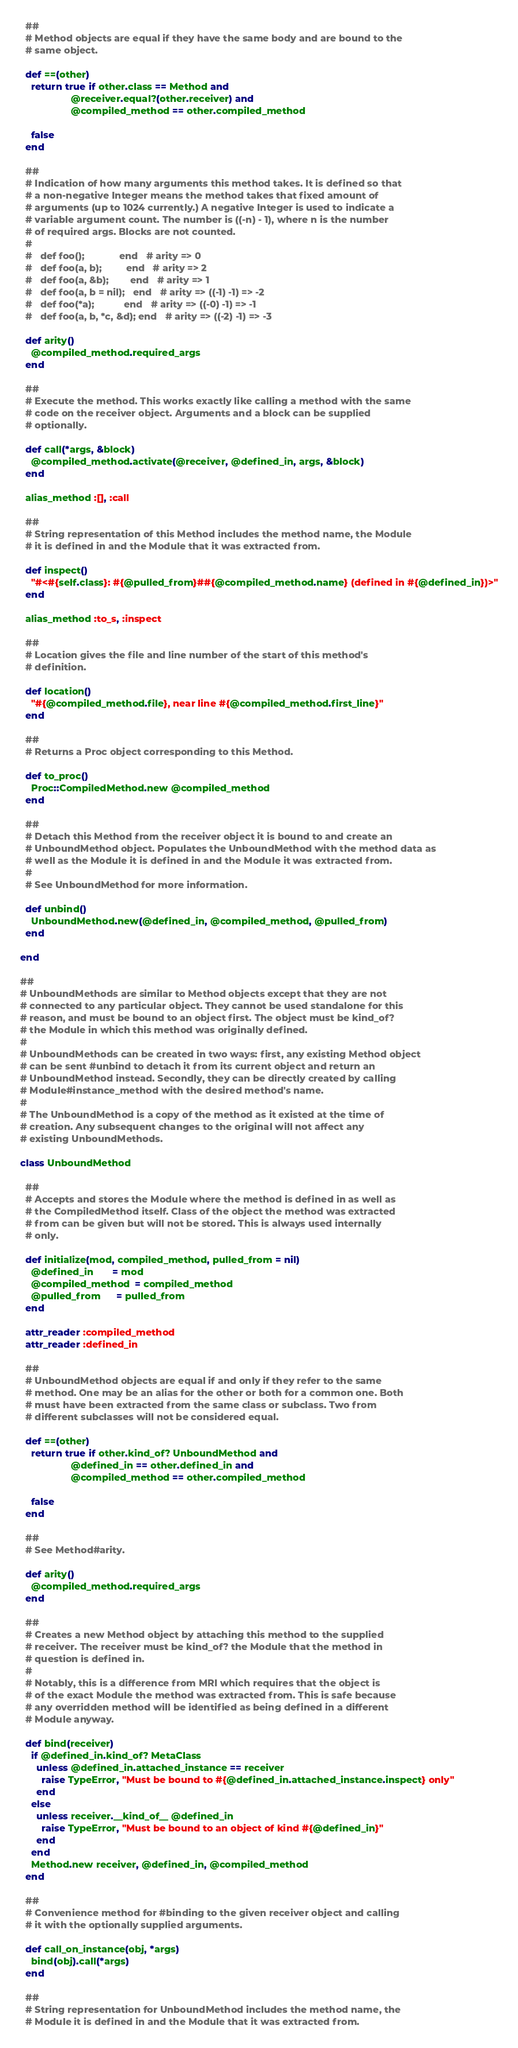Convert code to text. <code><loc_0><loc_0><loc_500><loc_500><_Ruby_>  ##
  # Method objects are equal if they have the same body and are bound to the
  # same object.

  def ==(other)
    return true if other.class == Method and
                   @receiver.equal?(other.receiver) and
                   @compiled_method == other.compiled_method

    false
  end

  ##
  # Indication of how many arguments this method takes. It is defined so that
  # a non-negative Integer means the method takes that fixed amount of
  # arguments (up to 1024 currently.) A negative Integer is used to indicate a
  # variable argument count. The number is ((-n) - 1), where n is the number
  # of required args. Blocks are not counted.
  #
  #   def foo();             end   # arity => 0
  #   def foo(a, b);         end   # arity => 2
  #   def foo(a, &b);        end   # arity => 1
  #   def foo(a, b = nil);   end   # arity => ((-1) -1) => -2
  #   def foo(*a);           end   # arity => ((-0) -1) => -1
  #   def foo(a, b, *c, &d); end   # arity => ((-2) -1) => -3

  def arity()
    @compiled_method.required_args
  end

  ##
  # Execute the method. This works exactly like calling a method with the same
  # code on the receiver object. Arguments and a block can be supplied
  # optionally.

  def call(*args, &block)
    @compiled_method.activate(@receiver, @defined_in, args, &block)
  end

  alias_method :[], :call

  ##
  # String representation of this Method includes the method name, the Module
  # it is defined in and the Module that it was extracted from.

  def inspect()
    "#<#{self.class}: #{@pulled_from}##{@compiled_method.name} (defined in #{@defined_in})>"
  end

  alias_method :to_s, :inspect

  ##
  # Location gives the file and line number of the start of this method's
  # definition.

  def location()
    "#{@compiled_method.file}, near line #{@compiled_method.first_line}"
  end

  ##
  # Returns a Proc object corresponding to this Method.

  def to_proc()
    Proc::CompiledMethod.new @compiled_method
  end

  ##
  # Detach this Method from the receiver object it is bound to and create an
  # UnboundMethod object. Populates the UnboundMethod with the method data as
  # well as the Module it is defined in and the Module it was extracted from.
  #
  # See UnboundMethod for more information.

  def unbind()
    UnboundMethod.new(@defined_in, @compiled_method, @pulled_from)
  end

end

##
# UnboundMethods are similar to Method objects except that they are not
# connected to any particular object. They cannot be used standalone for this
# reason, and must be bound to an object first. The object must be kind_of?
# the Module in which this method was originally defined.
#
# UnboundMethods can be created in two ways: first, any existing Method object
# can be sent #unbind to detach it from its current object and return an
# UnboundMethod instead. Secondly, they can be directly created by calling
# Module#instance_method with the desired method's name.
#
# The UnboundMethod is a copy of the method as it existed at the time of
# creation. Any subsequent changes to the original will not affect any
# existing UnboundMethods.

class UnboundMethod

  ##
  # Accepts and stores the Module where the method is defined in as well as
  # the CompiledMethod itself. Class of the object the method was extracted
  # from can be given but will not be stored. This is always used internally
  # only.

  def initialize(mod, compiled_method, pulled_from = nil)
    @defined_in       = mod
    @compiled_method  = compiled_method
    @pulled_from      = pulled_from
  end

  attr_reader :compiled_method
  attr_reader :defined_in

  ##
  # UnboundMethod objects are equal if and only if they refer to the same
  # method. One may be an alias for the other or both for a common one. Both
  # must have been extracted from the same class or subclass. Two from
  # different subclasses will not be considered equal.

  def ==(other)
    return true if other.kind_of? UnboundMethod and
                   @defined_in == other.defined_in and
                   @compiled_method == other.compiled_method

    false
  end

  ##
  # See Method#arity.

  def arity()
    @compiled_method.required_args
  end

  ##
  # Creates a new Method object by attaching this method to the supplied
  # receiver. The receiver must be kind_of? the Module that the method in
  # question is defined in.
  #
  # Notably, this is a difference from MRI which requires that the object is
  # of the exact Module the method was extracted from. This is safe because
  # any overridden method will be identified as being defined in a different
  # Module anyway.

  def bind(receiver)
    if @defined_in.kind_of? MetaClass
      unless @defined_in.attached_instance == receiver
        raise TypeError, "Must be bound to #{@defined_in.attached_instance.inspect} only"
      end
    else
      unless receiver.__kind_of__ @defined_in
        raise TypeError, "Must be bound to an object of kind #{@defined_in}"
      end
    end
    Method.new receiver, @defined_in, @compiled_method
  end

  ##
  # Convenience method for #binding to the given receiver object and calling
  # it with the optionally supplied arguments.

  def call_on_instance(obj, *args)
    bind(obj).call(*args)
  end

  ##
  # String representation for UnboundMethod includes the method name, the
  # Module it is defined in and the Module that it was extracted from.
</code> 